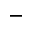<formula> <loc_0><loc_0><loc_500><loc_500>-</formula> 